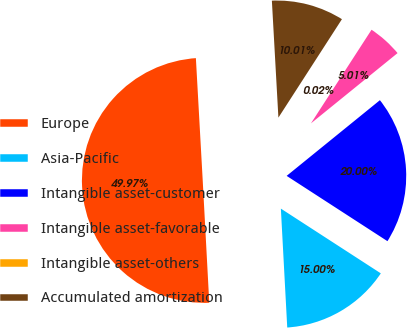Convert chart. <chart><loc_0><loc_0><loc_500><loc_500><pie_chart><fcel>Europe<fcel>Asia-Pacific<fcel>Intangible asset-customer<fcel>Intangible asset-favorable<fcel>Intangible asset-others<fcel>Accumulated amortization<nl><fcel>49.97%<fcel>15.0%<fcel>20.0%<fcel>5.01%<fcel>0.02%<fcel>10.01%<nl></chart> 